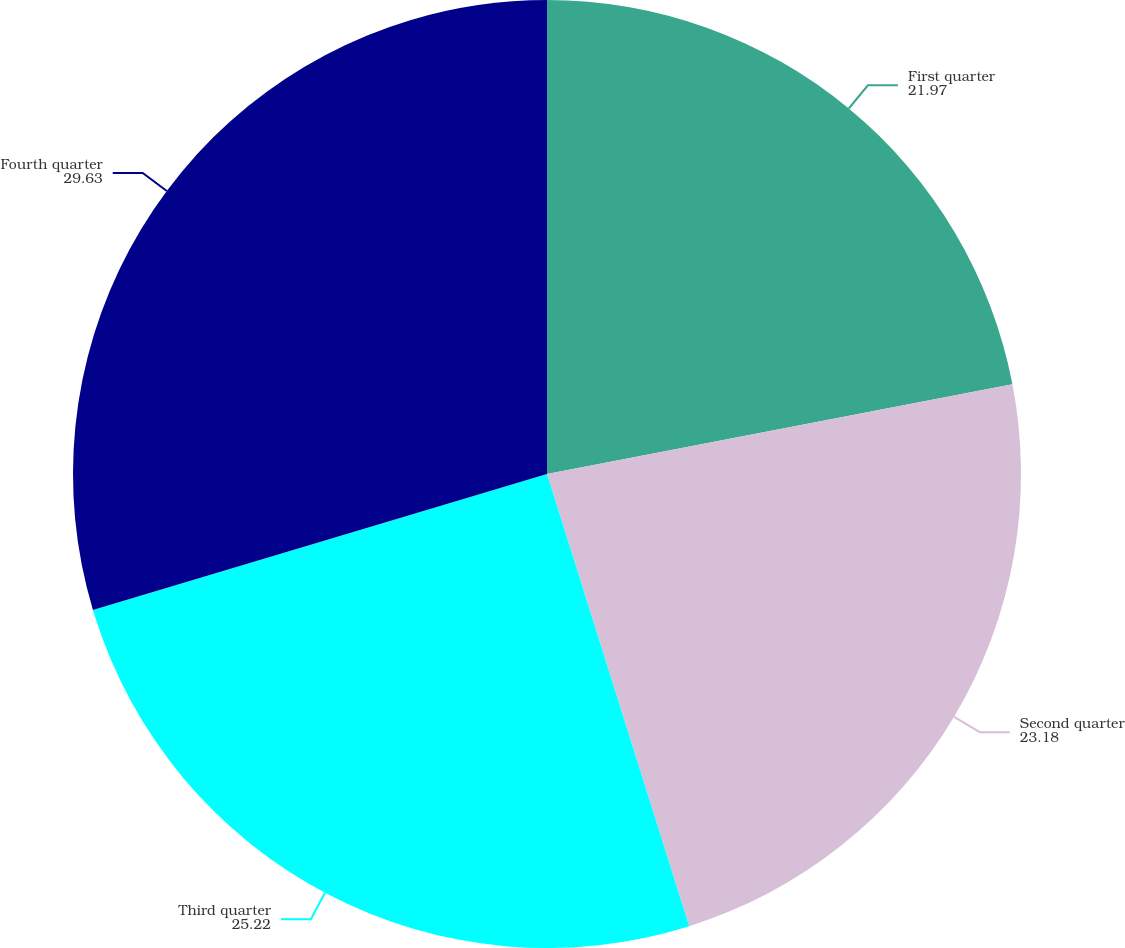Convert chart to OTSL. <chart><loc_0><loc_0><loc_500><loc_500><pie_chart><fcel>First quarter<fcel>Second quarter<fcel>Third quarter<fcel>Fourth quarter<nl><fcel>21.97%<fcel>23.18%<fcel>25.22%<fcel>29.63%<nl></chart> 